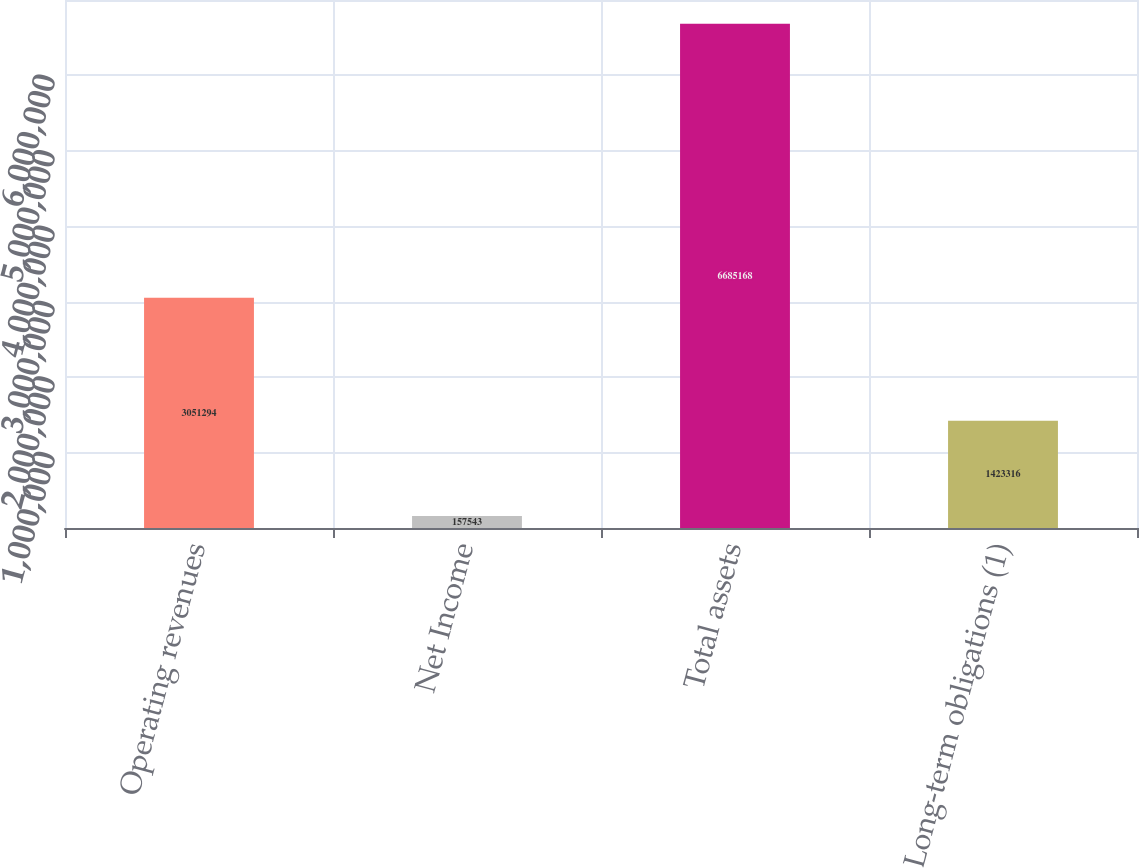<chart> <loc_0><loc_0><loc_500><loc_500><bar_chart><fcel>Operating revenues<fcel>Net Income<fcel>Total assets<fcel>Long-term obligations (1)<nl><fcel>3.05129e+06<fcel>157543<fcel>6.68517e+06<fcel>1.42332e+06<nl></chart> 